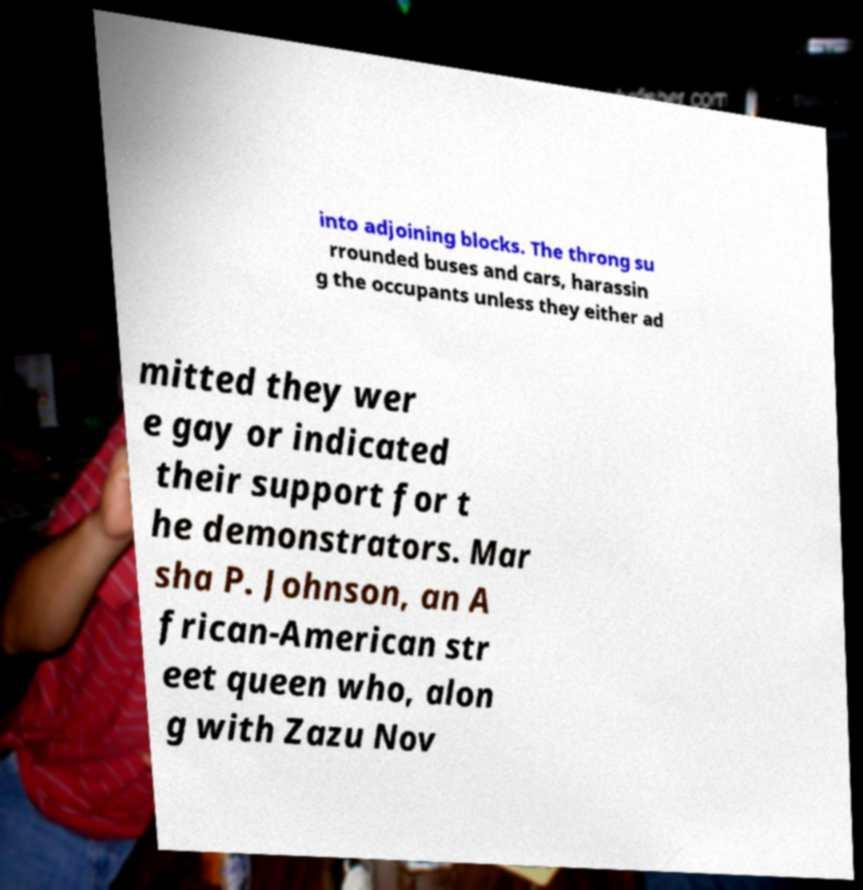What messages or text are displayed in this image? I need them in a readable, typed format. into adjoining blocks. The throng su rrounded buses and cars, harassin g the occupants unless they either ad mitted they wer e gay or indicated their support for t he demonstrators. Mar sha P. Johnson, an A frican-American str eet queen who, alon g with Zazu Nov 